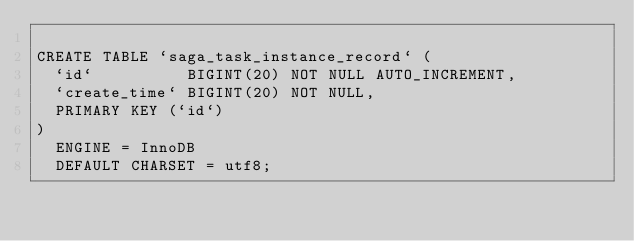<code> <loc_0><loc_0><loc_500><loc_500><_SQL_>
CREATE TABLE `saga_task_instance_record` (
  `id`          BIGINT(20) NOT NULL AUTO_INCREMENT,
  `create_time` BIGINT(20) NOT NULL,
  PRIMARY KEY (`id`)
)
  ENGINE = InnoDB
  DEFAULT CHARSET = utf8;</code> 